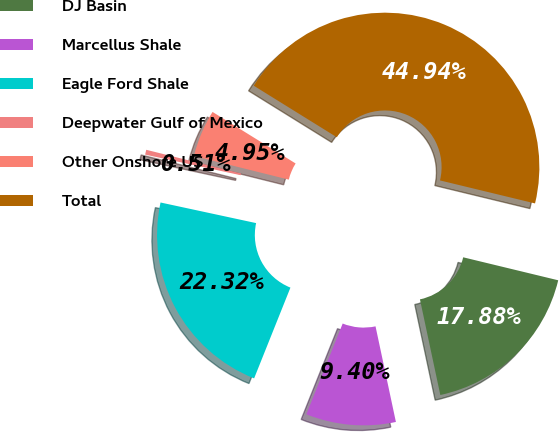Convert chart to OTSL. <chart><loc_0><loc_0><loc_500><loc_500><pie_chart><fcel>DJ Basin<fcel>Marcellus Shale<fcel>Eagle Ford Shale<fcel>Deepwater Gulf of Mexico<fcel>Other Onshore US<fcel>Total<nl><fcel>17.88%<fcel>9.4%<fcel>22.32%<fcel>0.51%<fcel>4.95%<fcel>44.94%<nl></chart> 